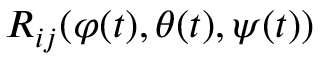Convert formula to latex. <formula><loc_0><loc_0><loc_500><loc_500>R _ { i j } ( \varphi ( t ) , \theta ( t ) , \psi ( t ) )</formula> 